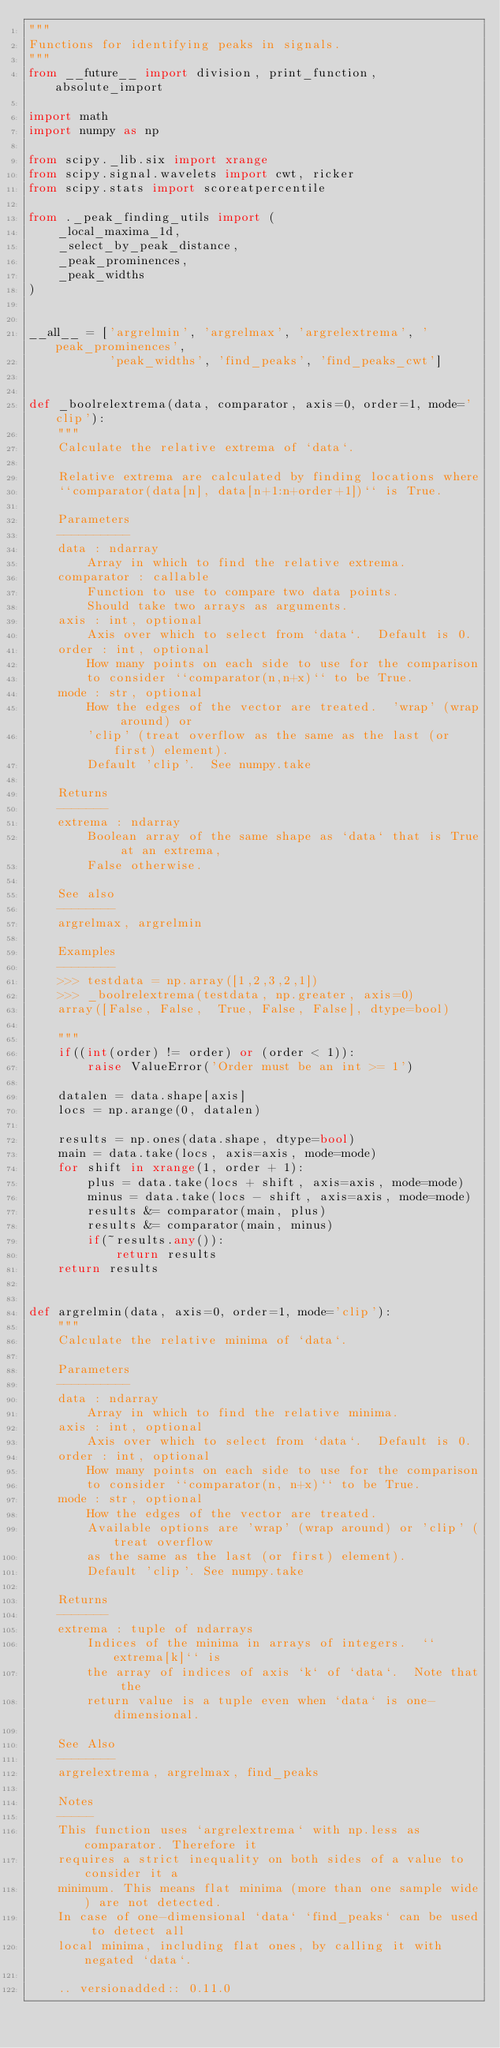Convert code to text. <code><loc_0><loc_0><loc_500><loc_500><_Python_>"""
Functions for identifying peaks in signals.
"""
from __future__ import division, print_function, absolute_import

import math
import numpy as np

from scipy._lib.six import xrange
from scipy.signal.wavelets import cwt, ricker
from scipy.stats import scoreatpercentile

from ._peak_finding_utils import (
    _local_maxima_1d,
    _select_by_peak_distance,
    _peak_prominences,
    _peak_widths
)


__all__ = ['argrelmin', 'argrelmax', 'argrelextrema', 'peak_prominences',
           'peak_widths', 'find_peaks', 'find_peaks_cwt']


def _boolrelextrema(data, comparator, axis=0, order=1, mode='clip'):
    """
    Calculate the relative extrema of `data`.

    Relative extrema are calculated by finding locations where
    ``comparator(data[n], data[n+1:n+order+1])`` is True.

    Parameters
    ----------
    data : ndarray
        Array in which to find the relative extrema.
    comparator : callable
        Function to use to compare two data points.
        Should take two arrays as arguments.
    axis : int, optional
        Axis over which to select from `data`.  Default is 0.
    order : int, optional
        How many points on each side to use for the comparison
        to consider ``comparator(n,n+x)`` to be True.
    mode : str, optional
        How the edges of the vector are treated.  'wrap' (wrap around) or
        'clip' (treat overflow as the same as the last (or first) element).
        Default 'clip'.  See numpy.take

    Returns
    -------
    extrema : ndarray
        Boolean array of the same shape as `data` that is True at an extrema,
        False otherwise.

    See also
    --------
    argrelmax, argrelmin

    Examples
    --------
    >>> testdata = np.array([1,2,3,2,1])
    >>> _boolrelextrema(testdata, np.greater, axis=0)
    array([False, False,  True, False, False], dtype=bool)

    """
    if((int(order) != order) or (order < 1)):
        raise ValueError('Order must be an int >= 1')

    datalen = data.shape[axis]
    locs = np.arange(0, datalen)

    results = np.ones(data.shape, dtype=bool)
    main = data.take(locs, axis=axis, mode=mode)
    for shift in xrange(1, order + 1):
        plus = data.take(locs + shift, axis=axis, mode=mode)
        minus = data.take(locs - shift, axis=axis, mode=mode)
        results &= comparator(main, plus)
        results &= comparator(main, minus)
        if(~results.any()):
            return results
    return results


def argrelmin(data, axis=0, order=1, mode='clip'):
    """
    Calculate the relative minima of `data`.

    Parameters
    ----------
    data : ndarray
        Array in which to find the relative minima.
    axis : int, optional
        Axis over which to select from `data`.  Default is 0.
    order : int, optional
        How many points on each side to use for the comparison
        to consider ``comparator(n, n+x)`` to be True.
    mode : str, optional
        How the edges of the vector are treated.
        Available options are 'wrap' (wrap around) or 'clip' (treat overflow
        as the same as the last (or first) element).
        Default 'clip'. See numpy.take

    Returns
    -------
    extrema : tuple of ndarrays
        Indices of the minima in arrays of integers.  ``extrema[k]`` is
        the array of indices of axis `k` of `data`.  Note that the
        return value is a tuple even when `data` is one-dimensional.

    See Also
    --------
    argrelextrema, argrelmax, find_peaks

    Notes
    -----
    This function uses `argrelextrema` with np.less as comparator. Therefore it
    requires a strict inequality on both sides of a value to consider it a
    minimum. This means flat minima (more than one sample wide) are not detected.
    In case of one-dimensional `data` `find_peaks` can be used to detect all
    local minima, including flat ones, by calling it with negated `data`.

    .. versionadded:: 0.11.0
</code> 